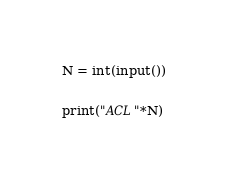<code> <loc_0><loc_0><loc_500><loc_500><_Python_>N = int(input())

print("ACL"*N)</code> 